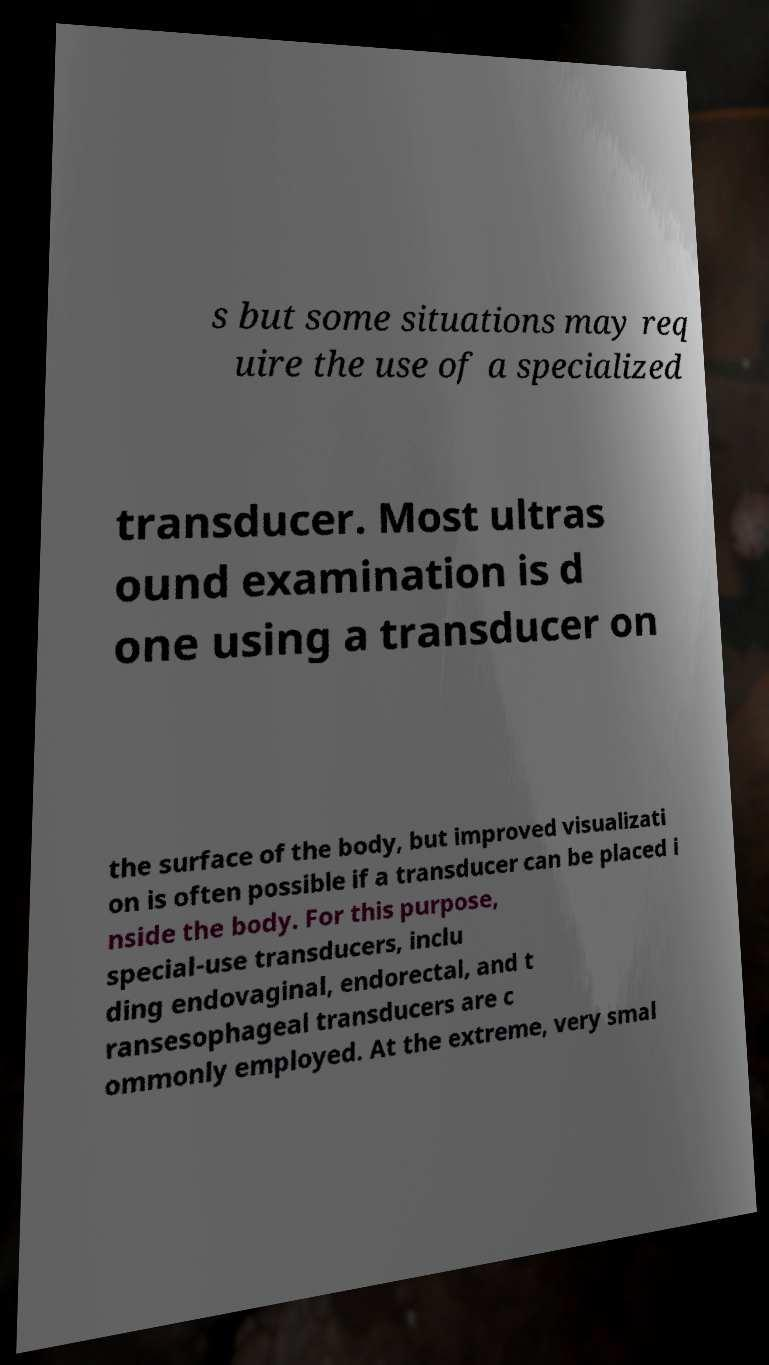I need the written content from this picture converted into text. Can you do that? s but some situations may req uire the use of a specialized transducer. Most ultras ound examination is d one using a transducer on the surface of the body, but improved visualizati on is often possible if a transducer can be placed i nside the body. For this purpose, special-use transducers, inclu ding endovaginal, endorectal, and t ransesophageal transducers are c ommonly employed. At the extreme, very smal 